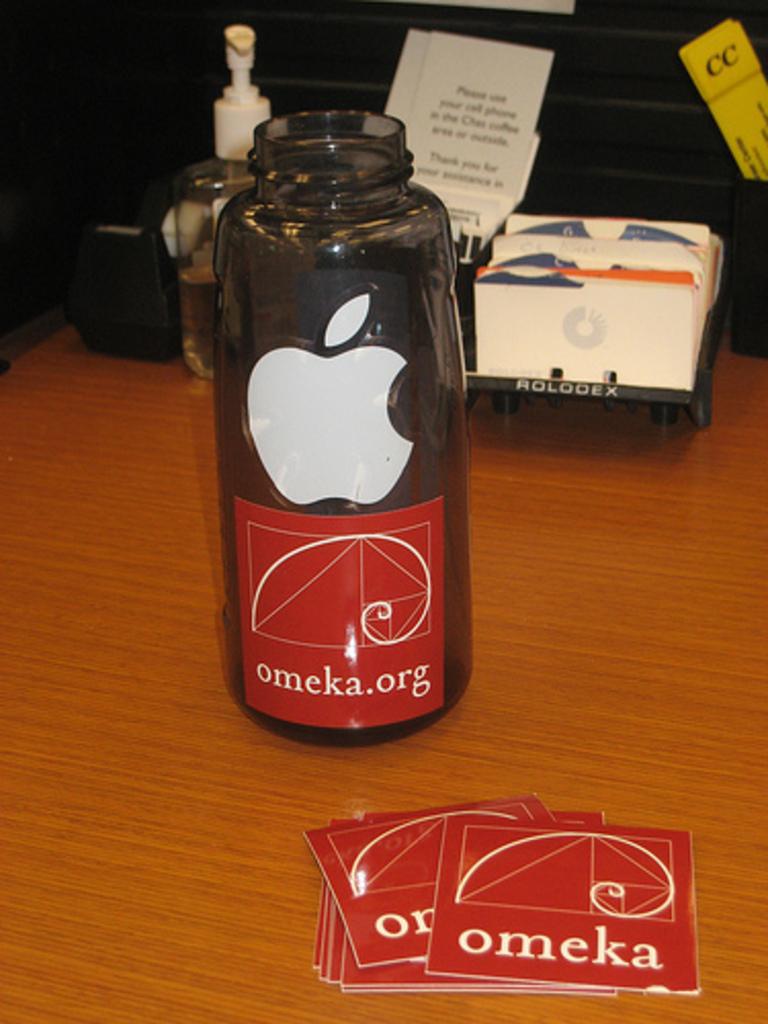What dies the coaster say?
Your answer should be very brief. Omeka. What is the website?
Offer a terse response. Omeka.org. 